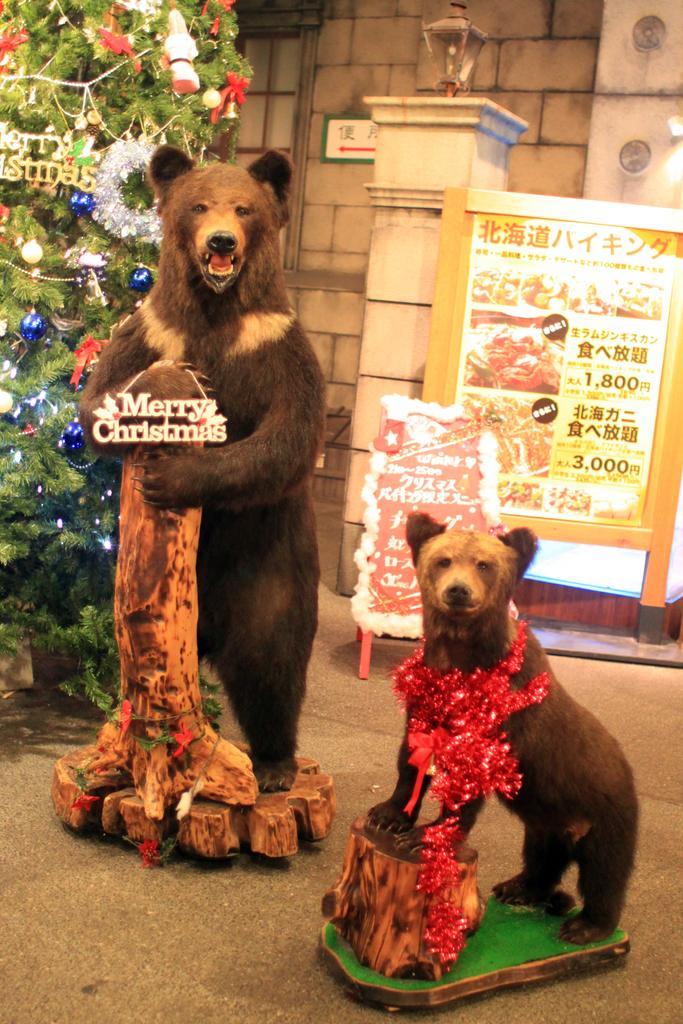How would you summarize this image in a sentence or two? In this picture we can observe two bears. One of the bear is holding a wooden log and the other beat is standing on the wooden log. We can observe a tree which was decorated with lights in the left side. In the background there is a poster and a wall. 